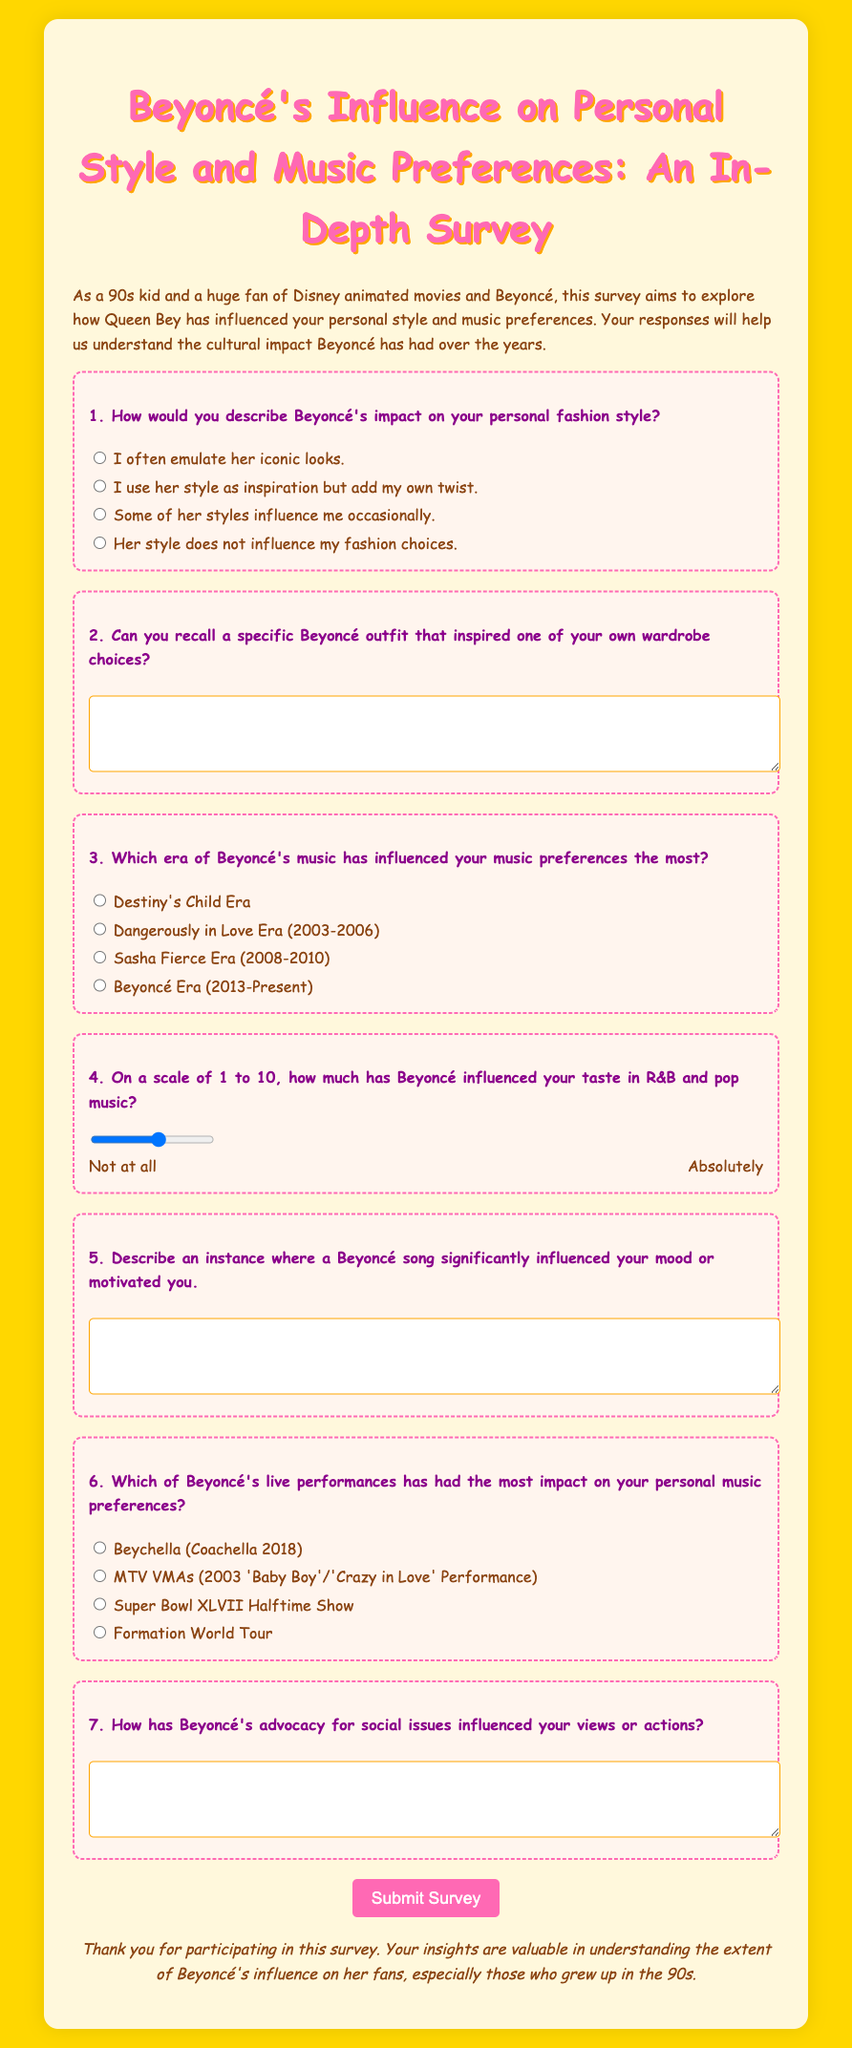What is the title of the survey? The title of the survey is provided in the document as the main heading, which is "Beyoncé's Influence on Personal Style and Music Preferences: An In-Depth Survey."
Answer: Beyoncé's Influence on Personal Style and Music Preferences: An In-Depth Survey How many main questions are included in the survey? The document outlines a total of seven main questions directed at understanding Beyoncé's influence, which can be counted.
Answer: 7 What is the color of the background in the document? The background color of the document is specified in the style section as #FFD700, which corresponds to a gold color.
Answer: #FFD700 Which era of Beyoncé's music includes the song "Crazy in Love"? In the survey, "Crazy in Love" is referenced under the option for the MTV VMAs (2003 'Baby Boy'/'Crazy in Love' Performance).
Answer: 2003 What specific event does "Beychella" refer to in the document? "Beychella" is mentioned as her performance at Coachella in 2018, highlighting its significance in the context of her live performances.
Answer: Coachella 2018 How is the survey aimed at a specific demographic? The introduction of the survey explicitly mentions that it targets those who grew up in the 90s, linking to a cultural context shared by many respondents.
Answer: 90s kids On a scale of what numbers does the survey ask about Beyoncé's influence on music taste? The survey asks participants to rate Beyoncé's influence on a scale from 1 to 10 regarding their taste in R&B and pop music.
Answer: 1 to 10 What is the main purpose of this survey? The purpose as mentioned in the introduction is to explore how Beyoncé has influenced personal style and music preferences among her fans.
Answer: Explore influence 